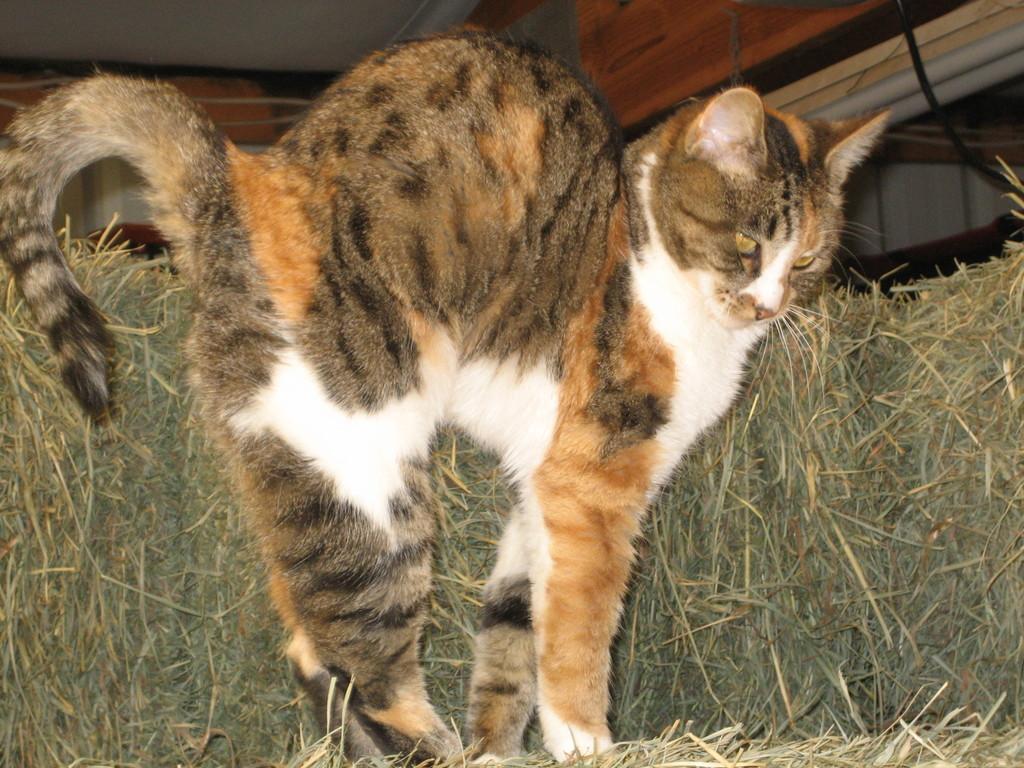Please provide a concise description of this image. In this image I can see a cat is standing. I can see colour of this cat is white, cream and grey. In the background I can see grass. 